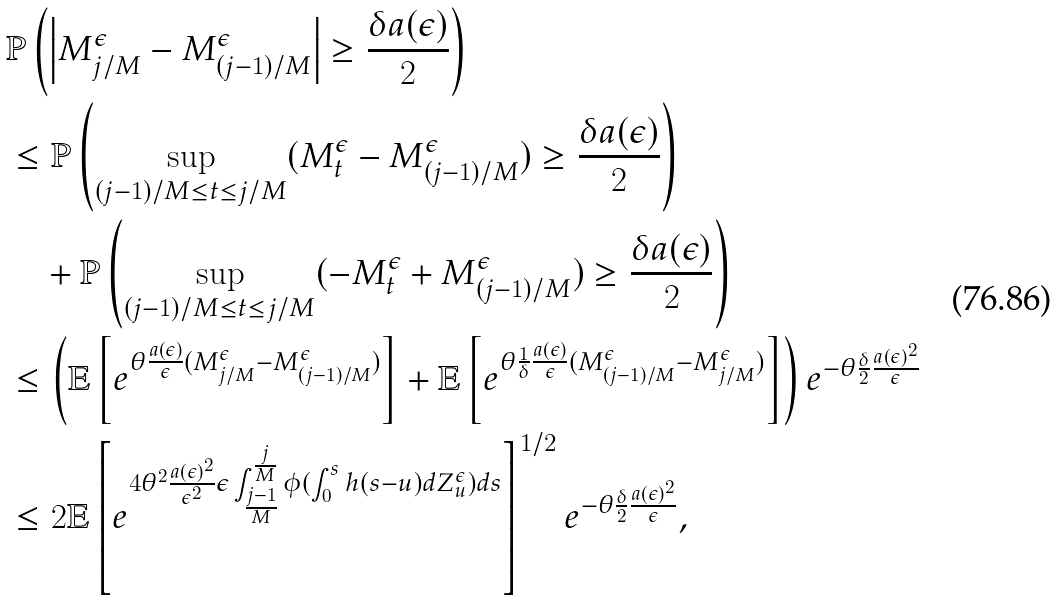Convert formula to latex. <formula><loc_0><loc_0><loc_500><loc_500>& \mathbb { P } \left ( \left | M _ { j / M } ^ { \epsilon } - M _ { ( j - 1 ) / M } ^ { \epsilon } \right | \geq \frac { \delta a ( \epsilon ) } { 2 } \right ) \\ & \leq \mathbb { P } \left ( \sup _ { ( j - 1 ) / M \leq t \leq j / M } ( M _ { t } ^ { \epsilon } - M _ { ( j - 1 ) / M } ^ { \epsilon } ) \geq \frac { \delta a ( \epsilon ) } { 2 } \right ) \\ & \quad + \mathbb { P } \left ( \sup _ { ( j - 1 ) / M \leq t \leq j / M } ( - M _ { t } ^ { \epsilon } + M _ { ( j - 1 ) / M } ^ { \epsilon } ) \geq \frac { \delta a ( \epsilon ) } { 2 } \right ) \\ & \leq \left ( \mathbb { E } \left [ e ^ { \theta \frac { a ( \epsilon ) } { \epsilon } ( M _ { j / M } ^ { \epsilon } - M _ { ( j - 1 ) / M } ^ { \epsilon } ) } \right ] + \mathbb { E } \left [ e ^ { \theta \frac { 1 } { \delta } \frac { a ( \epsilon ) } { \epsilon } ( M _ { ( j - 1 ) / M } ^ { \epsilon } - M _ { j / M } ^ { \epsilon } ) } \right ] \right ) e ^ { - \theta \frac { \delta } { 2 } \frac { a ( \epsilon ) ^ { 2 } } { \epsilon } } \\ & \leq 2 \mathbb { E } \left [ e ^ { 4 \theta ^ { 2 } \frac { a ( \epsilon ) ^ { 2 } } { \epsilon ^ { 2 } } \epsilon \int _ { \frac { j - 1 } { M } } ^ { \frac { j } { M } } \phi ( \int _ { 0 } ^ { s } h ( s - u ) d Z _ { u } ^ { \epsilon } ) d s } \right ] ^ { 1 / 2 } e ^ { - \theta \frac { \delta } { 2 } \frac { a ( \epsilon ) ^ { 2 } } { \epsilon } } ,</formula> 